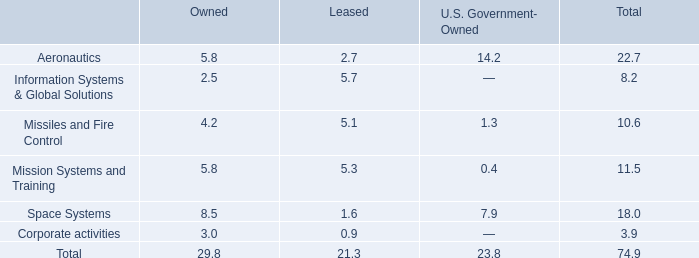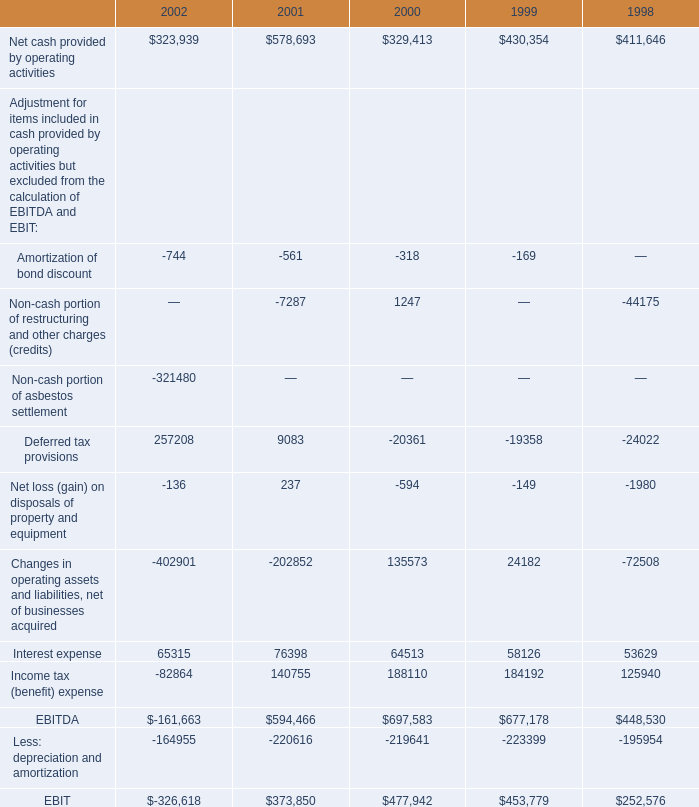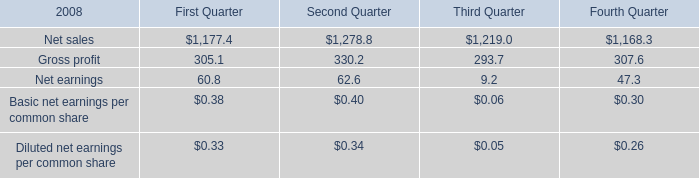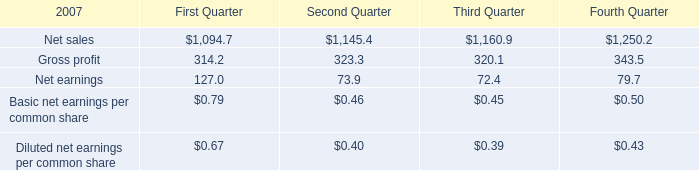what's the total amount of Net sales of Second Quarter, and Net sales of Fourth Quarter ? 
Computations: (1145.4 + 1168.3)
Answer: 2313.7. 